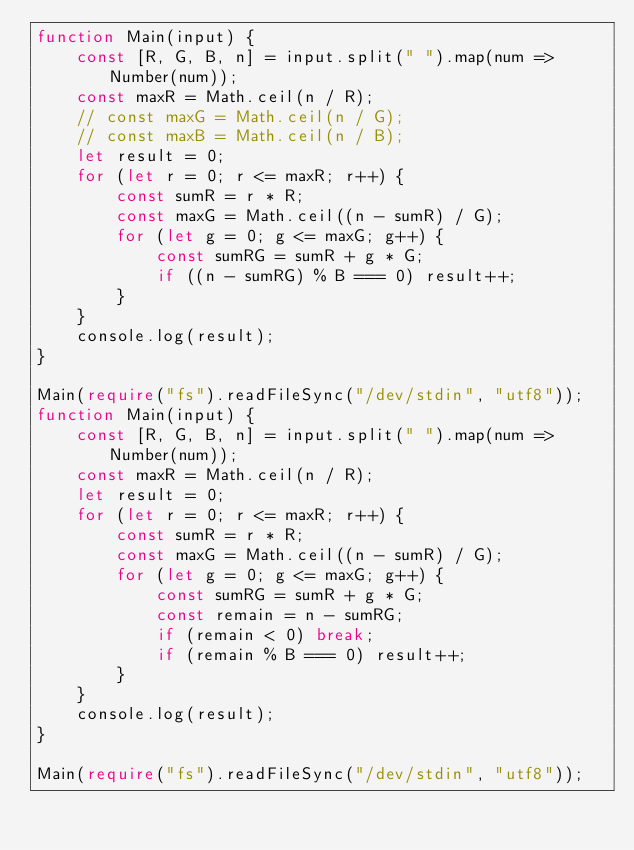Convert code to text. <code><loc_0><loc_0><loc_500><loc_500><_TypeScript_>function Main(input) {
    const [R, G, B, n] = input.split(" ").map(num => Number(num));
    const maxR = Math.ceil(n / R);
    // const maxG = Math.ceil(n / G);
    // const maxB = Math.ceil(n / B);
    let result = 0;
    for (let r = 0; r <= maxR; r++) {
        const sumR = r * R;
        const maxG = Math.ceil((n - sumR) / G);
        for (let g = 0; g <= maxG; g++) {
            const sumRG = sumR + g * G;
            if ((n - sumRG) % B === 0) result++;
        }
    }
    console.log(result);
}
 
Main(require("fs").readFileSync("/dev/stdin", "utf8"));
function Main(input) {
    const [R, G, B, n] = input.split(" ").map(num => Number(num));
    const maxR = Math.ceil(n / R);
    let result = 0;
    for (let r = 0; r <= maxR; r++) {
        const sumR = r * R;
        const maxG = Math.ceil((n - sumR) / G);
        for (let g = 0; g <= maxG; g++) {
            const sumRG = sumR + g * G;
            const remain = n - sumRG;
            if (remain < 0) break;
            if (remain % B === 0) result++;
        }
    }
    console.log(result);
}

Main(require("fs").readFileSync("/dev/stdin", "utf8"));</code> 